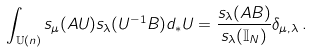<formula> <loc_0><loc_0><loc_500><loc_500>\int _ { \mathbb { U } ( n ) } s _ { \mu } ( A U ) s _ { \lambda } ( U ^ { - 1 } B ) d _ { * } U = \frac { s _ { \lambda } ( A B ) } { s _ { \lambda } ( \mathbb { I } _ { N } ) } \delta _ { \mu , \lambda } \, .</formula> 